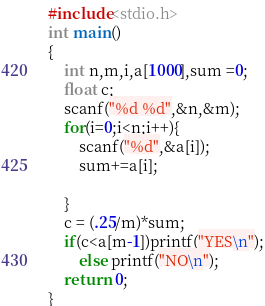Convert code to text. <code><loc_0><loc_0><loc_500><loc_500><_C_>#include<stdio.h>
int main()
{
    int n,m,i,a[1000],sum =0;
    float c;
    scanf("%d %d",&n,&m);
    for(i=0;i<n;i++){
        scanf("%d",&a[i]);
        sum+=a[i];

    }
    c = (.25/m)*sum;
    if(c<a[m-1])printf("YES\n");
        else printf("NO\n");
    return 0;
}
</code> 